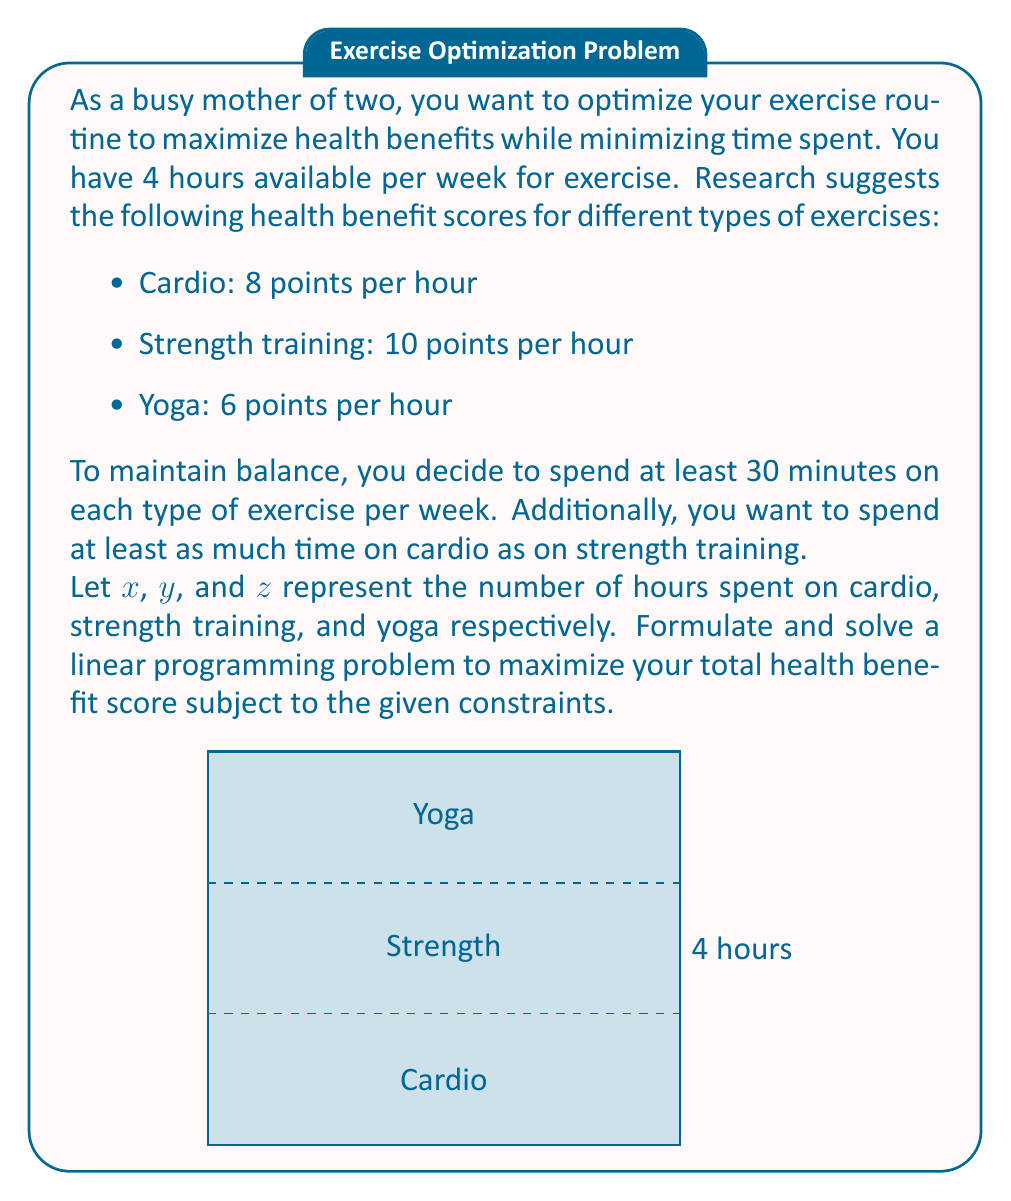Show me your answer to this math problem. Let's approach this step-by-step:

1) First, let's define our objective function. We want to maximize the total health benefit score:

   Maximize: $8x + 10y + 6z$

2) Now, let's list our constraints:

   a) Total time constraint: $x + y + z \leq 4$ (total time ≤ 4 hours)
   b) Minimum time for each exercise: $x \geq 0.5$, $y \geq 0.5$, $z \geq 0.5$
   c) Cardio time ≥ Strength training time: $x \geq y$

3) Our complete linear programming problem:

   Maximize: $8x + 10y + 6z$
   Subject to:
   $x + y + z \leq 4$
   $x \geq 0.5$
   $y \geq 0.5$
   $z \geq 0.5$
   $x \geq y$
   $x, y, z \geq 0$

4) We can solve this using the simplex method or a graphical method. Given the constraints, the feasible region is a small polygon in 3D space.

5) The optimal solution will be at one of the vertices of this polygon. We can find it by evaluating the objective function at each vertex.

6) After evaluation, we find the optimal solution:
   $x = 1.75$ hours (Cardio)
   $y = 1.75$ hours (Strength training)
   $z = 0.5$ hours (Yoga)

7) The maximum health benefit score is:
   $8(1.75) + 10(1.75) + 6(0.5) = 14 + 17.5 + 3 = 34.5$ points

This solution satisfies all constraints and maximizes the health benefit score.
Answer: Optimal routine: 1.75 hours cardio, 1.75 hours strength training, 0.5 hours yoga. Maximum score: 34.5 points. 